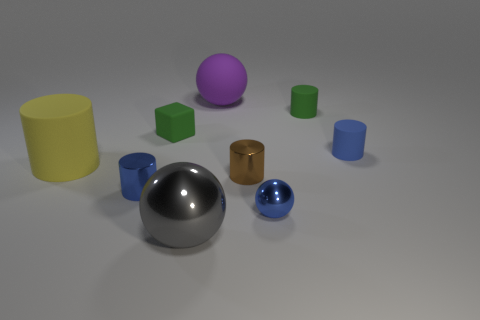Is the number of tiny rubber things less than the number of large yellow matte objects?
Give a very brief answer. No. What is the shape of the blue thing that is to the right of the large shiny thing and on the left side of the blue matte cylinder?
Keep it short and to the point. Sphere. How many small yellow things are there?
Provide a succinct answer. 0. The tiny blue cylinder to the left of the large thing that is in front of the large thing that is on the left side of the blue shiny cylinder is made of what material?
Ensure brevity in your answer.  Metal. There is a brown shiny cylinder on the left side of the tiny blue matte cylinder; what number of tiny cylinders are in front of it?
Ensure brevity in your answer.  1. What is the color of the tiny thing that is the same shape as the large purple thing?
Your answer should be very brief. Blue. Is the material of the small green block the same as the big yellow object?
Offer a very short reply. Yes. What number of balls are either big metallic things or big rubber objects?
Your response must be concise. 2. There is a green thing that is to the left of the tiny blue shiny object to the right of the tiny blue thing that is to the left of the large gray shiny ball; what is its size?
Your response must be concise. Small. What size is the brown metal object that is the same shape as the tiny blue rubber thing?
Offer a very short reply. Small. 